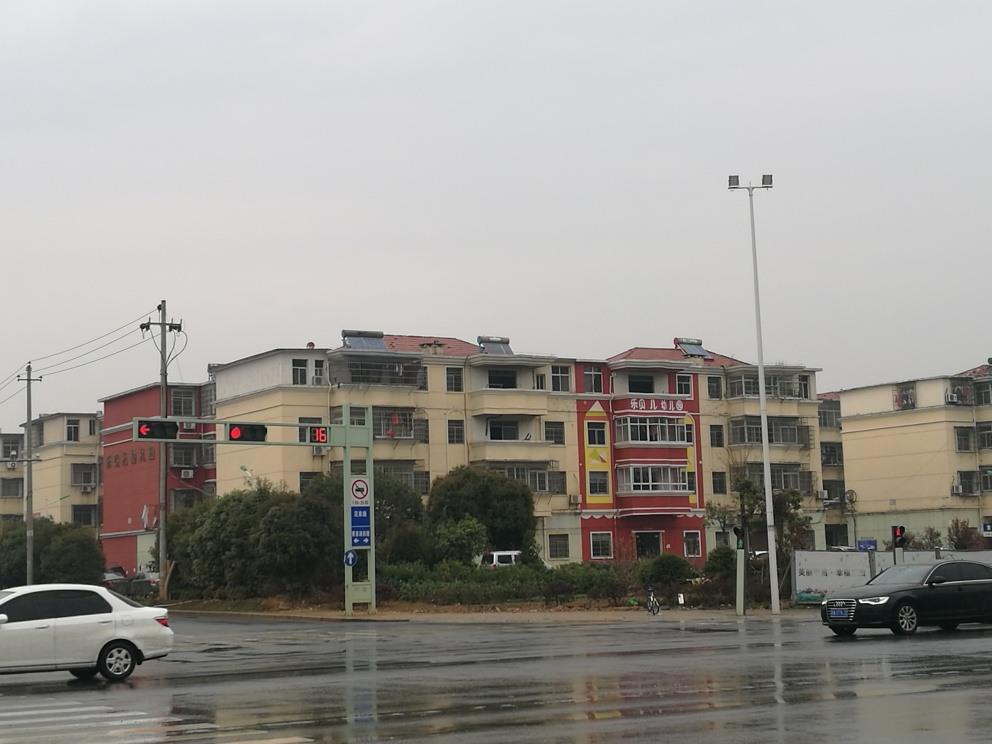How clear is the background of the image?
A. Obscured
B. Relatively clear
C. Blurry
D. Indistinct
Answer with the option's letter from the given choices directly.
 B. 